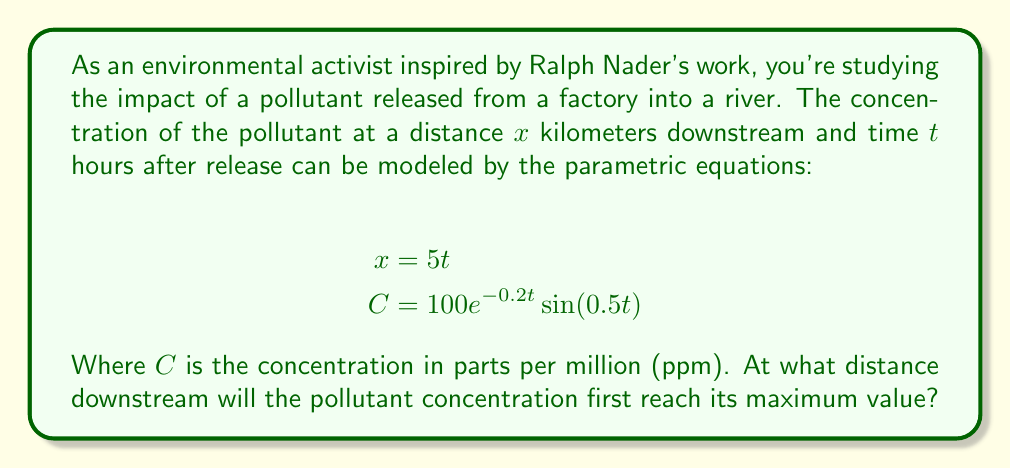Give your solution to this math problem. To solve this problem, we need to follow these steps:

1) First, we need to find when the concentration $C$ reaches its maximum value. This occurs when $\frac{dC}{dt} = 0$.

2) Let's calculate $\frac{dC}{dt}$ using the product rule:

   $$\frac{dC}{dt} = 100(-0.2e^{-0.2t}\sin(0.5t) + e^{-0.2t}0.5\cos(0.5t))$$
   $$= 100e^{-0.2t}(-0.2\sin(0.5t) + 0.5\cos(0.5t))$$

3) Setting this equal to zero:

   $$100e^{-0.2t}(-0.2\sin(0.5t) + 0.5\cos(0.5t)) = 0$$

4) The exponential term is always positive, so we can divide both sides by $100e^{-0.2t}$:

   $$-0.2\sin(0.5t) + 0.5\cos(0.5t) = 0$$

5) Dividing by 0.5:

   $$-0.4\sin(0.5t) + \cos(0.5t) = 0$$

6) This is equivalent to:

   $$\tan(0.5t) = \frac{1}{0.4} = 2.5$$

7) Solving for $t$:

   $$0.5t = \arctan(2.5)$$
   $$t = 2\arctan(2.5) \approx 2.356$$

8) This is the time when the concentration first reaches its maximum. To find the distance, we use the equation for $x$:

   $$x = 5t = 5(2.356) \approx 11.78$$

Therefore, the pollutant concentration first reaches its maximum approximately 11.78 kilometers downstream.
Answer: The pollutant concentration first reaches its maximum approximately 11.78 kilometers downstream. 